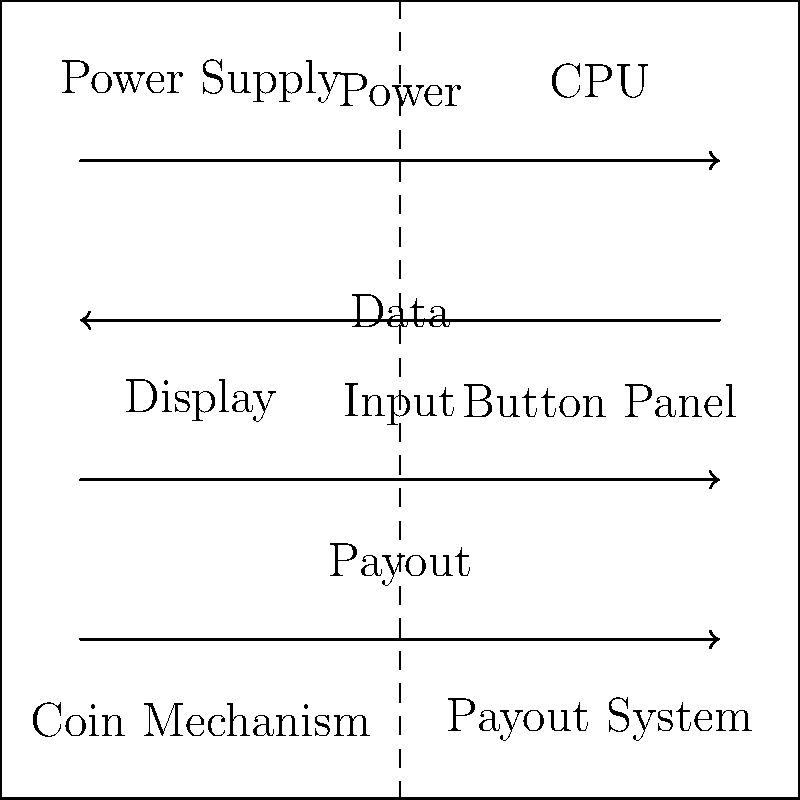In the simplified schematic of a typical casino slot machine, which component is directly responsible for processing game logic and determining winning combinations? To answer this question, let's break down the components of a typical casino slot machine as shown in the schematic:

1. Power Supply: Provides electrical power to all components.
2. CPU (Central Processing Unit): The brain of the machine, responsible for game logic and calculations.
3. Display: Shows game graphics and results to the player.
4. Button Panel: Allows player input for game interactions.
5. Coin Mechanism: Handles coin insertion and counting.
6. Payout System: Manages the dispensing of winnings.

The CPU is the central component that processes all the information and controls the machine's operations. It:

1. Receives input from the Button Panel and Coin Mechanism.
2. Runs the game software and random number generator.
3. Determines winning combinations based on the game's rules.
4. Sends display information to the Display component.
5. Instructs the Payout System when and how much to pay out.

Therefore, the CPU is directly responsible for processing game logic and determining winning combinations in a casino slot machine.
Answer: CPU (Central Processing Unit) 